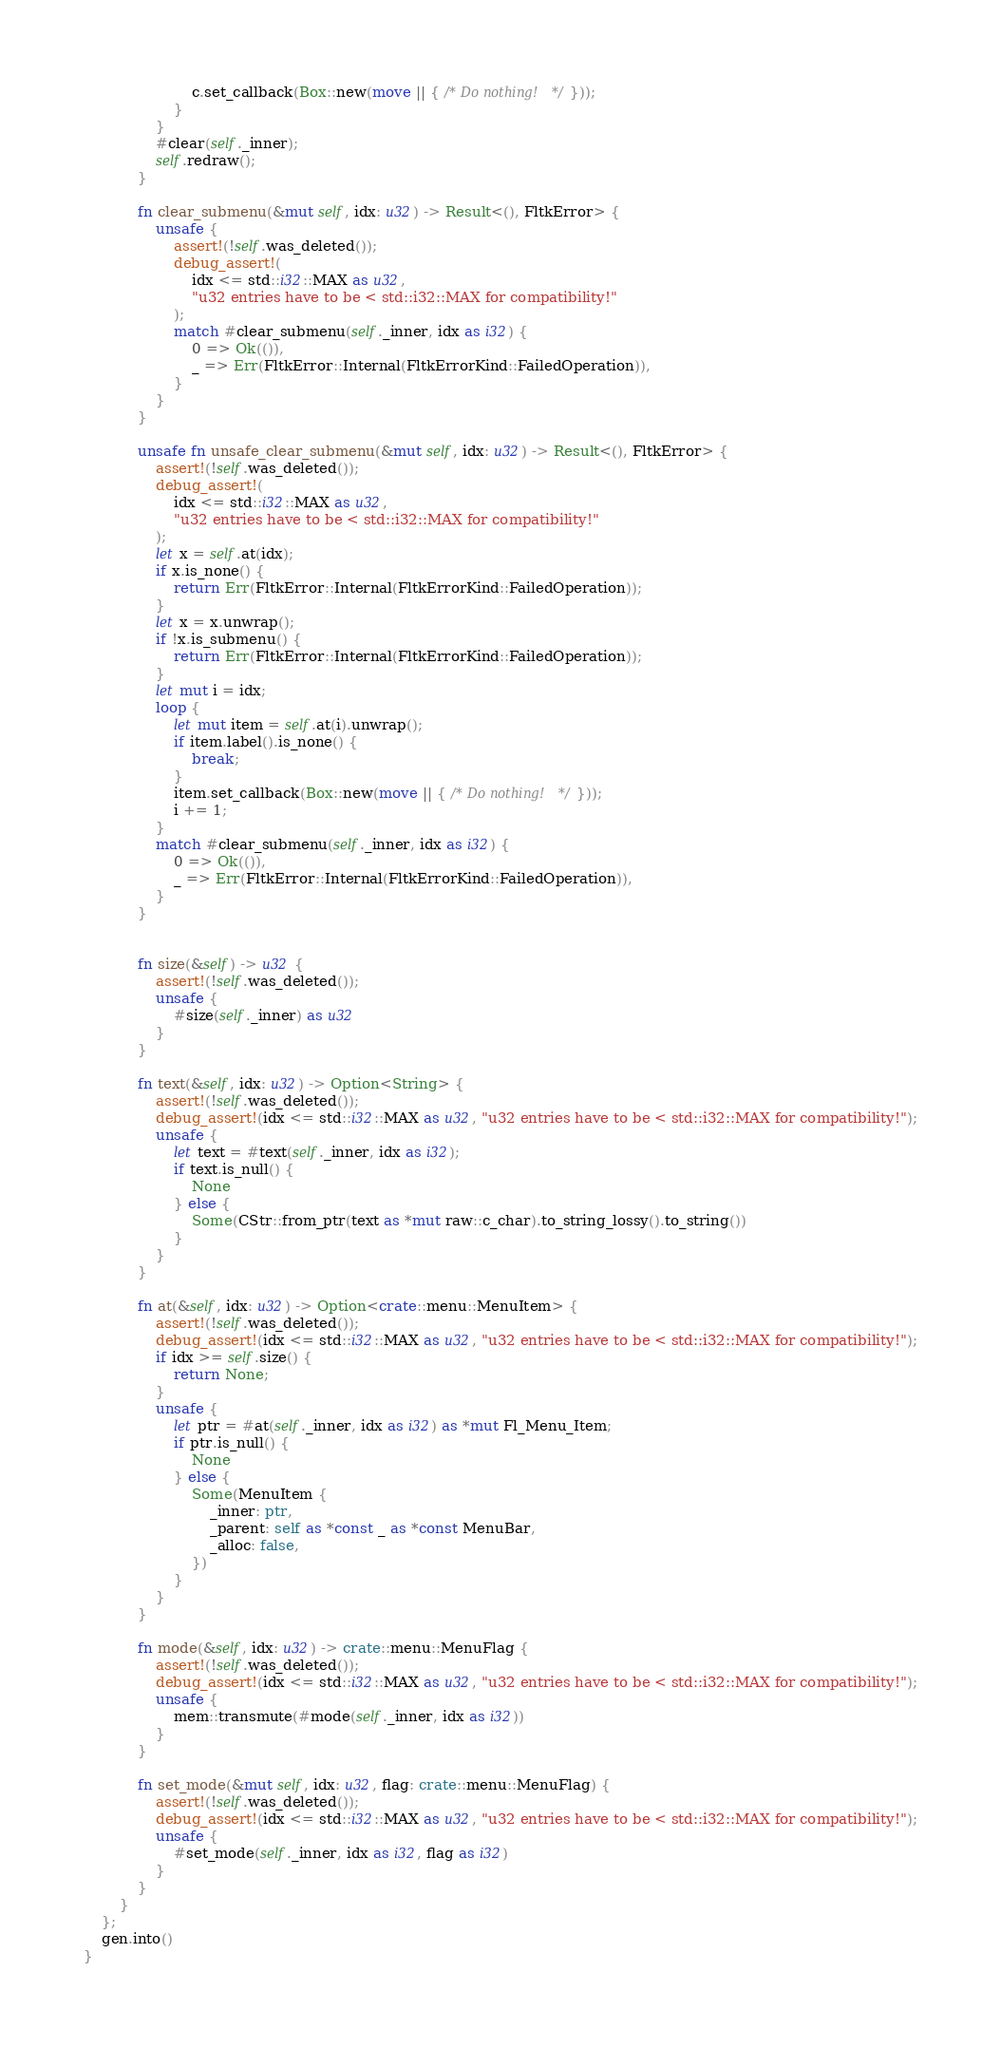Convert code to text. <code><loc_0><loc_0><loc_500><loc_500><_Rust_>                        c.set_callback(Box::new(move || { /* Do nothing! */ }));
                    }
                }
                #clear(self._inner);
                self.redraw();
            }

            fn clear_submenu(&mut self, idx: u32) -> Result<(), FltkError> {
                unsafe {
                    assert!(!self.was_deleted());
                    debug_assert!(
                        idx <= std::i32::MAX as u32,
                        "u32 entries have to be < std::i32::MAX for compatibility!"
                    );
                    match #clear_submenu(self._inner, idx as i32) {
                        0 => Ok(()),
                        _ => Err(FltkError::Internal(FltkErrorKind::FailedOperation)),
                    }
                }
            }

            unsafe fn unsafe_clear_submenu(&mut self, idx: u32) -> Result<(), FltkError> {
                assert!(!self.was_deleted());
                debug_assert!(
                    idx <= std::i32::MAX as u32,
                    "u32 entries have to be < std::i32::MAX for compatibility!"
                );
                let x = self.at(idx);
                if x.is_none() {
                    return Err(FltkError::Internal(FltkErrorKind::FailedOperation));
                }
                let x = x.unwrap();
                if !x.is_submenu() {
                    return Err(FltkError::Internal(FltkErrorKind::FailedOperation));
                }
                let mut i = idx;
                loop {
                    let mut item = self.at(i).unwrap();
                    if item.label().is_none() {
                        break;
                    }
                    item.set_callback(Box::new(move || { /* Do nothing! */ }));
                    i += 1;
                }
                match #clear_submenu(self._inner, idx as i32) {
                    0 => Ok(()),
                    _ => Err(FltkError::Internal(FltkErrorKind::FailedOperation)),
                }
            }


            fn size(&self) -> u32 {
                assert!(!self.was_deleted());
                unsafe {
                    #size(self._inner) as u32
                }
            }

            fn text(&self, idx: u32) -> Option<String> {
                assert!(!self.was_deleted());
                debug_assert!(idx <= std::i32::MAX as u32, "u32 entries have to be < std::i32::MAX for compatibility!");
                unsafe {
                    let text = #text(self._inner, idx as i32);
                    if text.is_null() {
                        None
                    } else {
                        Some(CStr::from_ptr(text as *mut raw::c_char).to_string_lossy().to_string())
                    }
                }
            }

            fn at(&self, idx: u32) -> Option<crate::menu::MenuItem> {
                assert!(!self.was_deleted());
                debug_assert!(idx <= std::i32::MAX as u32, "u32 entries have to be < std::i32::MAX for compatibility!");
                if idx >= self.size() {
                    return None;
                }
                unsafe {
                    let ptr = #at(self._inner, idx as i32) as *mut Fl_Menu_Item;
                    if ptr.is_null() {
                        None
                    } else {
                        Some(MenuItem {
                            _inner: ptr,
                            _parent: self as *const _ as *const MenuBar,
                            _alloc: false,
                        })
                    }
                }
            }

            fn mode(&self, idx: u32) -> crate::menu::MenuFlag {
                assert!(!self.was_deleted());
                debug_assert!(idx <= std::i32::MAX as u32, "u32 entries have to be < std::i32::MAX for compatibility!");
                unsafe {
                    mem::transmute(#mode(self._inner, idx as i32))
                }
            }

            fn set_mode(&mut self, idx: u32, flag: crate::menu::MenuFlag) {
                assert!(!self.was_deleted());
                debug_assert!(idx <= std::i32::MAX as u32, "u32 entries have to be < std::i32::MAX for compatibility!");
                unsafe {
                    #set_mode(self._inner, idx as i32, flag as i32)
                }
            }
        }
    };
    gen.into()
}
</code> 